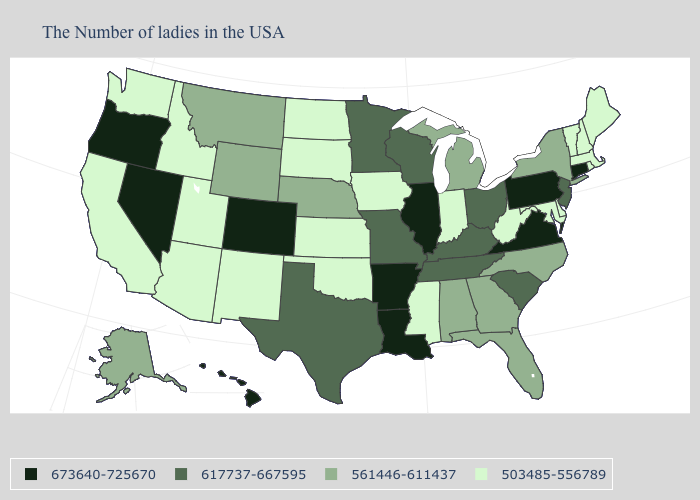Among the states that border Michigan , which have the lowest value?
Give a very brief answer. Indiana. Name the states that have a value in the range 503485-556789?
Give a very brief answer. Maine, Massachusetts, Rhode Island, New Hampshire, Vermont, Delaware, Maryland, West Virginia, Indiana, Mississippi, Iowa, Kansas, Oklahoma, South Dakota, North Dakota, New Mexico, Utah, Arizona, Idaho, California, Washington. Name the states that have a value in the range 617737-667595?
Keep it brief. New Jersey, South Carolina, Ohio, Kentucky, Tennessee, Wisconsin, Missouri, Minnesota, Texas. What is the value of Colorado?
Concise answer only. 673640-725670. Name the states that have a value in the range 617737-667595?
Concise answer only. New Jersey, South Carolina, Ohio, Kentucky, Tennessee, Wisconsin, Missouri, Minnesota, Texas. Name the states that have a value in the range 503485-556789?
Keep it brief. Maine, Massachusetts, Rhode Island, New Hampshire, Vermont, Delaware, Maryland, West Virginia, Indiana, Mississippi, Iowa, Kansas, Oklahoma, South Dakota, North Dakota, New Mexico, Utah, Arizona, Idaho, California, Washington. Among the states that border Missouri , which have the lowest value?
Keep it brief. Iowa, Kansas, Oklahoma. What is the value of Wyoming?
Concise answer only. 561446-611437. Which states have the lowest value in the Northeast?
Write a very short answer. Maine, Massachusetts, Rhode Island, New Hampshire, Vermont. Among the states that border Arkansas , which have the highest value?
Short answer required. Louisiana. Is the legend a continuous bar?
Keep it brief. No. Among the states that border Colorado , does Kansas have the lowest value?
Concise answer only. Yes. Does Illinois have the highest value in the MidWest?
Concise answer only. Yes. Does Virginia have the highest value in the South?
Write a very short answer. Yes. Name the states that have a value in the range 617737-667595?
Answer briefly. New Jersey, South Carolina, Ohio, Kentucky, Tennessee, Wisconsin, Missouri, Minnesota, Texas. 